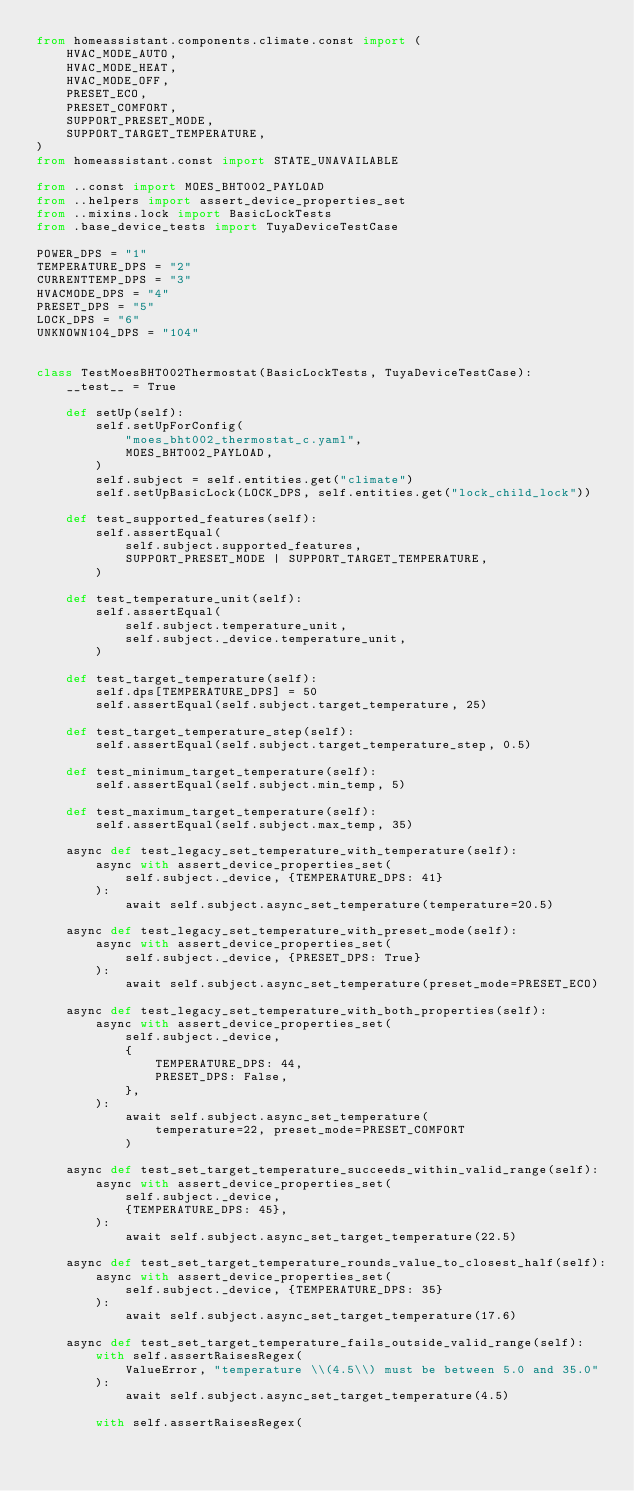Convert code to text. <code><loc_0><loc_0><loc_500><loc_500><_Python_>from homeassistant.components.climate.const import (
    HVAC_MODE_AUTO,
    HVAC_MODE_HEAT,
    HVAC_MODE_OFF,
    PRESET_ECO,
    PRESET_COMFORT,
    SUPPORT_PRESET_MODE,
    SUPPORT_TARGET_TEMPERATURE,
)
from homeassistant.const import STATE_UNAVAILABLE

from ..const import MOES_BHT002_PAYLOAD
from ..helpers import assert_device_properties_set
from ..mixins.lock import BasicLockTests
from .base_device_tests import TuyaDeviceTestCase

POWER_DPS = "1"
TEMPERATURE_DPS = "2"
CURRENTTEMP_DPS = "3"
HVACMODE_DPS = "4"
PRESET_DPS = "5"
LOCK_DPS = "6"
UNKNOWN104_DPS = "104"


class TestMoesBHT002Thermostat(BasicLockTests, TuyaDeviceTestCase):
    __test__ = True

    def setUp(self):
        self.setUpForConfig(
            "moes_bht002_thermostat_c.yaml",
            MOES_BHT002_PAYLOAD,
        )
        self.subject = self.entities.get("climate")
        self.setUpBasicLock(LOCK_DPS, self.entities.get("lock_child_lock"))

    def test_supported_features(self):
        self.assertEqual(
            self.subject.supported_features,
            SUPPORT_PRESET_MODE | SUPPORT_TARGET_TEMPERATURE,
        )

    def test_temperature_unit(self):
        self.assertEqual(
            self.subject.temperature_unit,
            self.subject._device.temperature_unit,
        )

    def test_target_temperature(self):
        self.dps[TEMPERATURE_DPS] = 50
        self.assertEqual(self.subject.target_temperature, 25)

    def test_target_temperature_step(self):
        self.assertEqual(self.subject.target_temperature_step, 0.5)

    def test_minimum_target_temperature(self):
        self.assertEqual(self.subject.min_temp, 5)

    def test_maximum_target_temperature(self):
        self.assertEqual(self.subject.max_temp, 35)

    async def test_legacy_set_temperature_with_temperature(self):
        async with assert_device_properties_set(
            self.subject._device, {TEMPERATURE_DPS: 41}
        ):
            await self.subject.async_set_temperature(temperature=20.5)

    async def test_legacy_set_temperature_with_preset_mode(self):
        async with assert_device_properties_set(
            self.subject._device, {PRESET_DPS: True}
        ):
            await self.subject.async_set_temperature(preset_mode=PRESET_ECO)

    async def test_legacy_set_temperature_with_both_properties(self):
        async with assert_device_properties_set(
            self.subject._device,
            {
                TEMPERATURE_DPS: 44,
                PRESET_DPS: False,
            },
        ):
            await self.subject.async_set_temperature(
                temperature=22, preset_mode=PRESET_COMFORT
            )

    async def test_set_target_temperature_succeeds_within_valid_range(self):
        async with assert_device_properties_set(
            self.subject._device,
            {TEMPERATURE_DPS: 45},
        ):
            await self.subject.async_set_target_temperature(22.5)

    async def test_set_target_temperature_rounds_value_to_closest_half(self):
        async with assert_device_properties_set(
            self.subject._device, {TEMPERATURE_DPS: 35}
        ):
            await self.subject.async_set_target_temperature(17.6)

    async def test_set_target_temperature_fails_outside_valid_range(self):
        with self.assertRaisesRegex(
            ValueError, "temperature \\(4.5\\) must be between 5.0 and 35.0"
        ):
            await self.subject.async_set_target_temperature(4.5)

        with self.assertRaisesRegex(</code> 